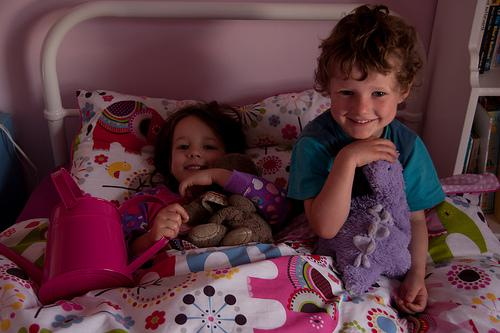Question: who is in the picture?
Choices:
A. A family are in the picture.
B. A circus crew are in the picture.
C. A little boy and a little girl is in the picture.
D. A group of artist are in the picture.
Answer with the letter. Answer: C Question: why are th kids smiling?
Choices:
A. Beause they are happy.
B. They have candy.
C. They are playing.
D. They are going home.
Answer with the letter. Answer: A Question: when was this picture taken?
Choices:
A. It was taken in the morning.
B. It was probably taken at night time.
C. It was taken at dusk.
D. It was taken in the evening.
Answer with the letter. Answer: B Question: what color is the little girls shirt?
Choices:
A. The little girl's shirt is red.
B. The little girls shirt is purple.
C. The little girl's shirt is yellow.
D. The little girl's shirt is pink.
Answer with the letter. Answer: B Question: where did this picture take place?
Choices:
A. It was taken in the kitchen.
B. This picture took place in the kids bedroom.
C. At the zoo.
D. In a classroom.
Answer with the letter. Answer: B Question: what color is the wall?
Choices:
A. The wall is pink.
B. The wall is yellow.
C. The wall is blue.
D. The wall is tan.
Answer with the letter. Answer: A Question: what color is the little boys shirt?
Choices:
A. The boy's shirt is yellow.
B. The boys shirt is green.
C. The boy's shirt is red.
D. The boy's shirt is purple.
Answer with the letter. Answer: B Question: how old do the kids look?
Choices:
A. The kids look 3-5 years old.
B. They look about 7 to 10 years old.
C. They appear to be 1 to 5 years old.
D. They seem to be 12-14 years old.
Answer with the letter. Answer: A 